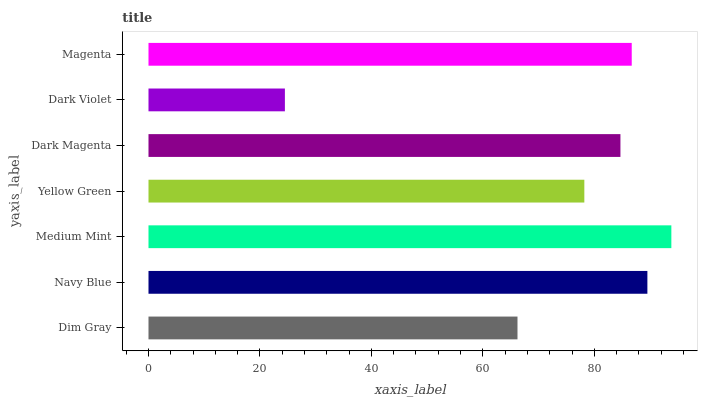Is Dark Violet the minimum?
Answer yes or no. Yes. Is Medium Mint the maximum?
Answer yes or no. Yes. Is Navy Blue the minimum?
Answer yes or no. No. Is Navy Blue the maximum?
Answer yes or no. No. Is Navy Blue greater than Dim Gray?
Answer yes or no. Yes. Is Dim Gray less than Navy Blue?
Answer yes or no. Yes. Is Dim Gray greater than Navy Blue?
Answer yes or no. No. Is Navy Blue less than Dim Gray?
Answer yes or no. No. Is Dark Magenta the high median?
Answer yes or no. Yes. Is Dark Magenta the low median?
Answer yes or no. Yes. Is Yellow Green the high median?
Answer yes or no. No. Is Magenta the low median?
Answer yes or no. No. 